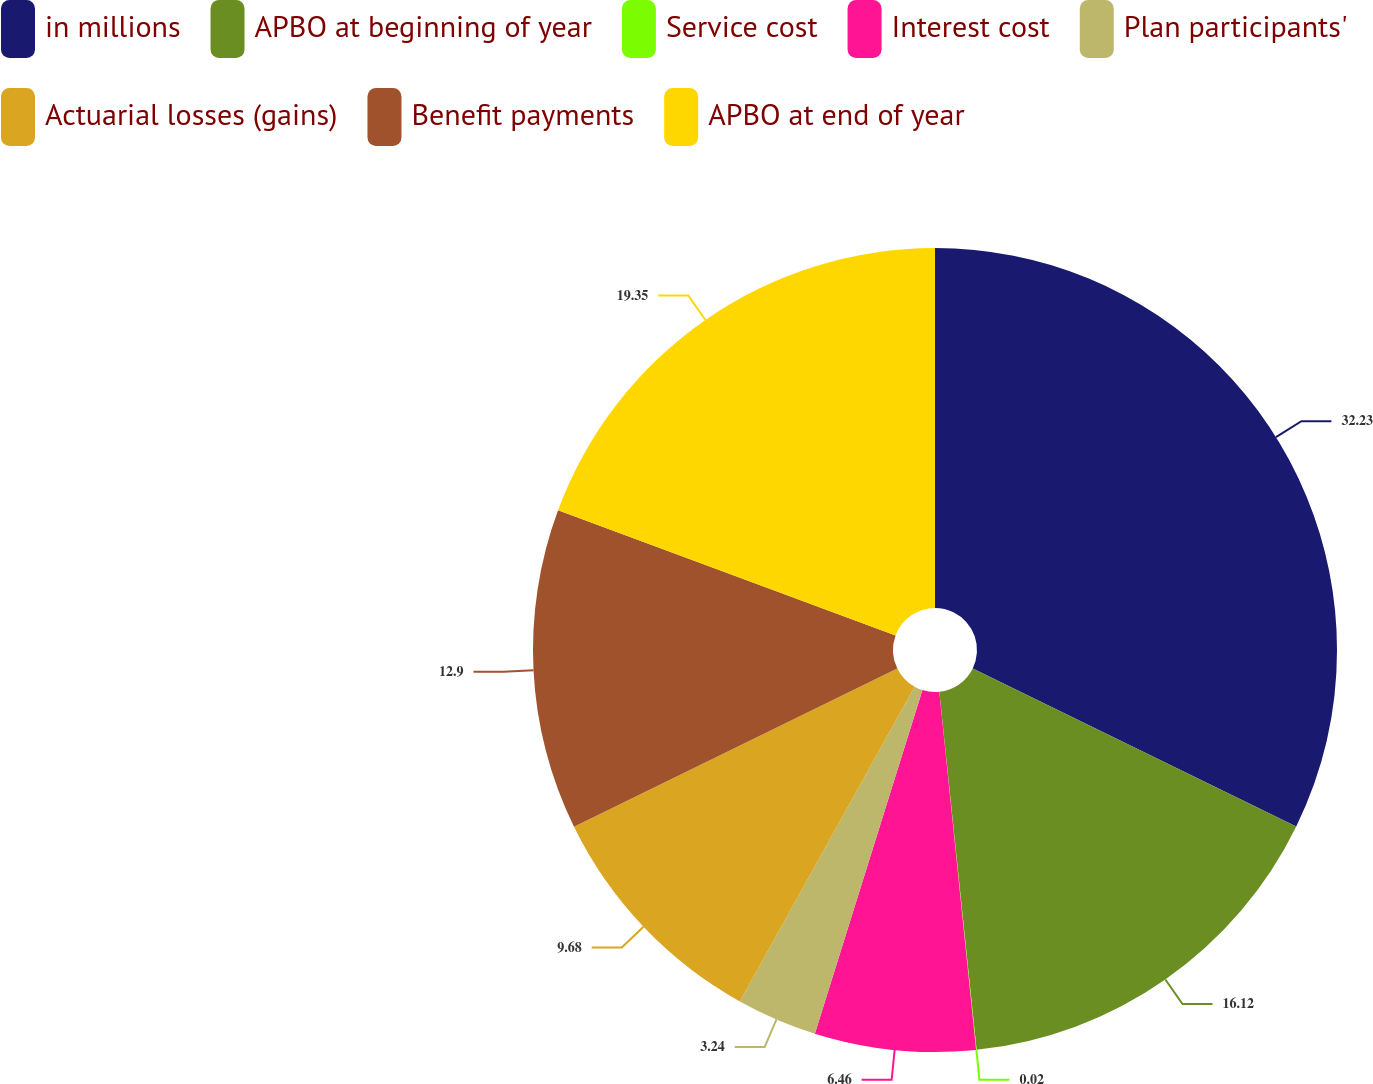Convert chart to OTSL. <chart><loc_0><loc_0><loc_500><loc_500><pie_chart><fcel>in millions<fcel>APBO at beginning of year<fcel>Service cost<fcel>Interest cost<fcel>Plan participants'<fcel>Actuarial losses (gains)<fcel>Benefit payments<fcel>APBO at end of year<nl><fcel>32.23%<fcel>16.12%<fcel>0.02%<fcel>6.46%<fcel>3.24%<fcel>9.68%<fcel>12.9%<fcel>19.35%<nl></chart> 